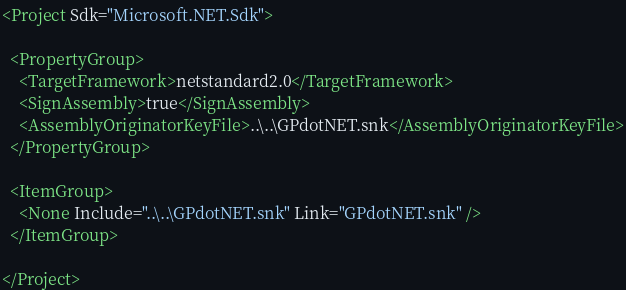Convert code to text. <code><loc_0><loc_0><loc_500><loc_500><_XML_><Project Sdk="Microsoft.NET.Sdk">

  <PropertyGroup>
    <TargetFramework>netstandard2.0</TargetFramework>
    <SignAssembly>true</SignAssembly>
    <AssemblyOriginatorKeyFile>..\..\GPdotNET.snk</AssemblyOriginatorKeyFile>
  </PropertyGroup>

  <ItemGroup>
    <None Include="..\..\GPdotNET.snk" Link="GPdotNET.snk" />
  </ItemGroup>

</Project>
</code> 